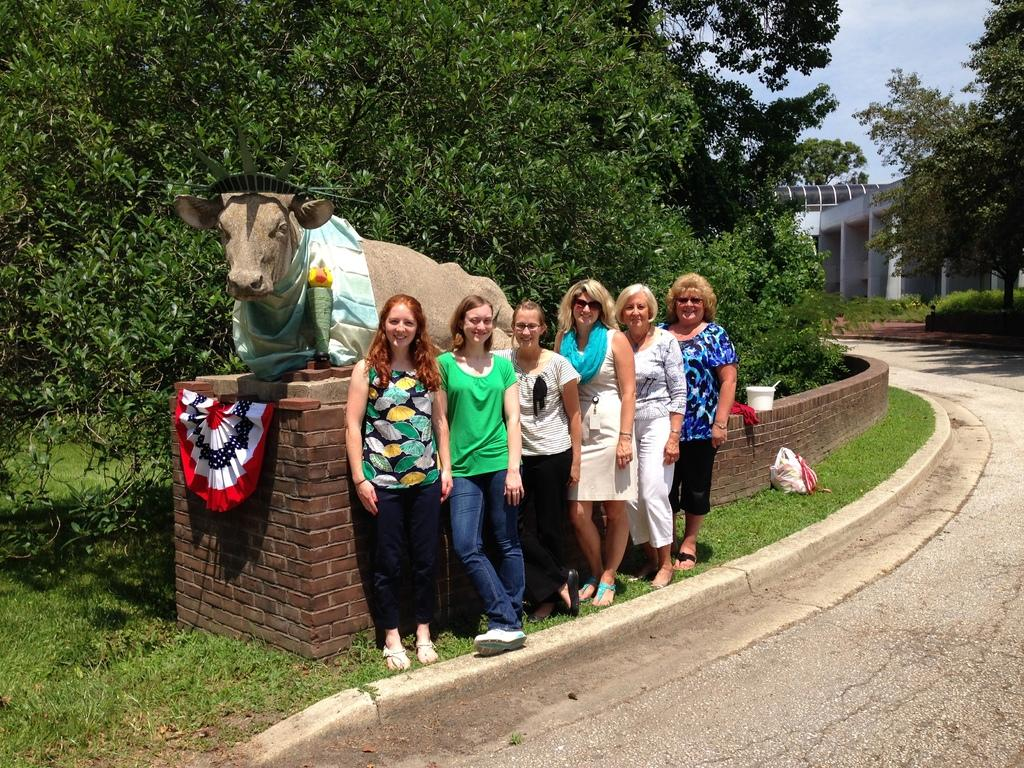What can be seen in the image? There are women standing in the image. What are the women standing beside? The women are beside a cow statue. Where is the cow statue located? The cow statue is on a grass field. What can be seen in the background of the image? There are trees in the background of the image. What is visible above the grass field and trees? The sky is visible in the image. What is the giraffe's interest in the cow statue? There is no giraffe present in the image, so it is not possible to determine its interest in the cow statue. 